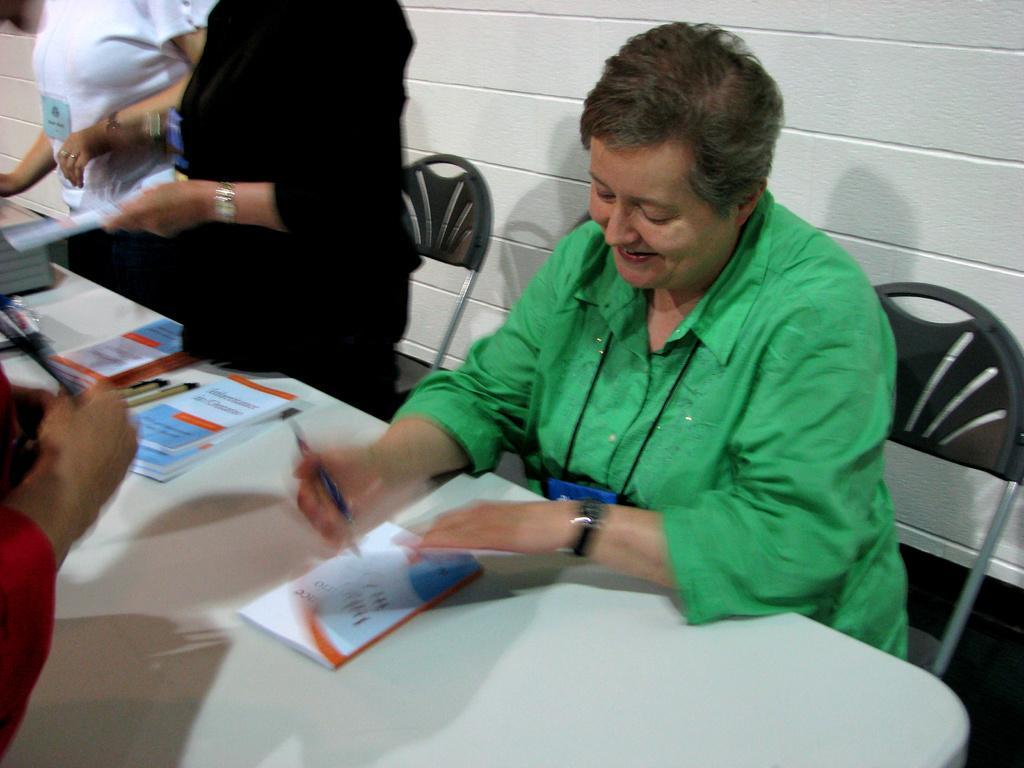In one or two sentences, can you explain what this image depicts? In this image we can see a person sitting on the chair and holding some objects. We can see a person at the left side of the image. There are two persons standing near the table. There are few books and objects placed on the tables. 